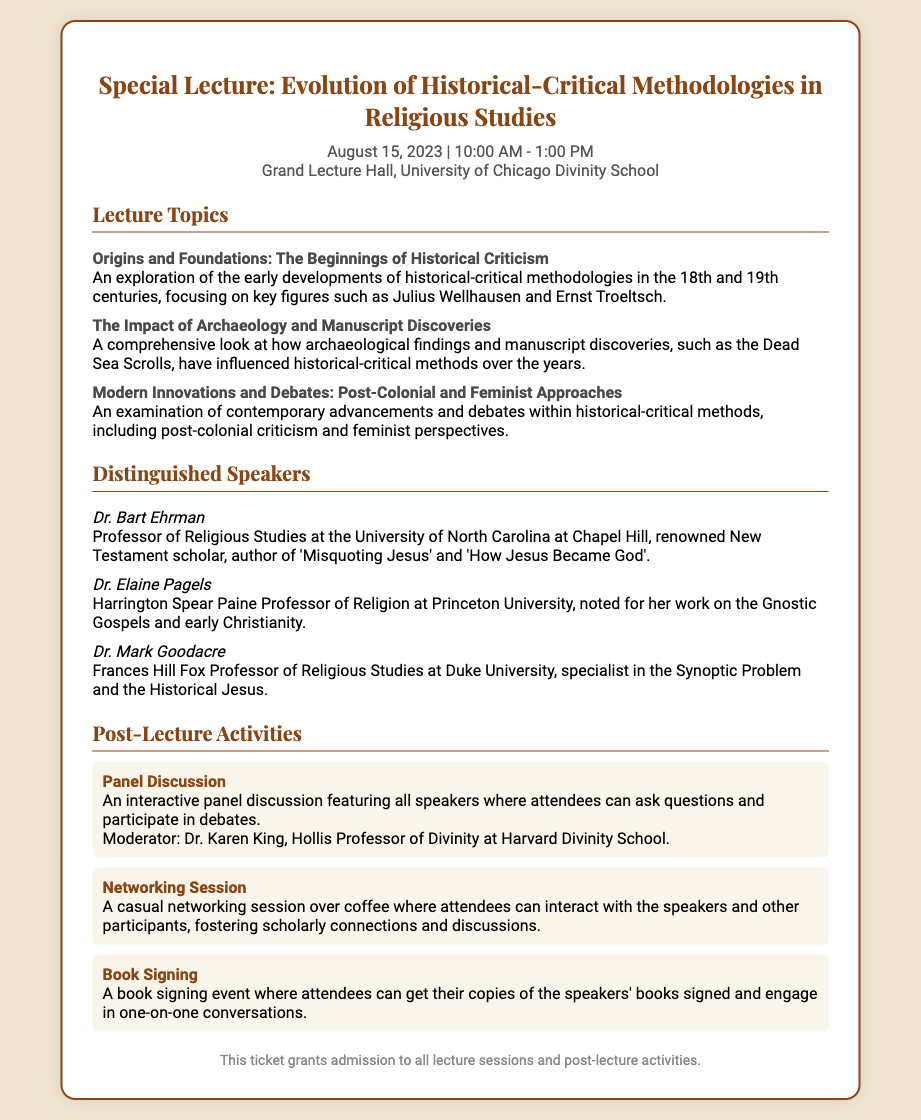What is the date of the special lecture? The date can be found in the event details section of the ticket, which states August 15, 2023.
Answer: August 15, 2023 Who is one of the distinguished speakers? The document lists distinguished speakers, including Dr. Bart Ehrman, Dr. Elaine Pagels, and Dr. Mark Goodacre.
Answer: Dr. Bart Ehrman What time does the special lecture start? The starting time is mentioned in the event details section, which states that it begins at 10:00 AM.
Answer: 10:00 AM What is one of the lecture topics? The document provides a list of lecture topics, such as "Origins and Foundations: The Beginnings of Historical Criticism."
Answer: Origins and Foundations: The Beginnings of Historical Criticism Who moderates the panel discussion? The moderator's name is provided in the post-lecture activities section, which mentions Dr. Karen King.
Answer: Dr. Karen King How long is the special lecture scheduled to last? The duration of the lecture can be inferred from the start and end times given, from 10:00 AM to 1:00 PM, which is three hours long.
Answer: 3 hours What type of session follows the lecture? The post-lecture activities section lists a variety of activities, including a networking session.
Answer: Networking Session What is the primary location of the event? The location is specified in the event details, stating it takes place at the Grand Lecture Hall, University of Chicago Divinity School.
Answer: Grand Lecture Hall, University of Chicago Divinity School 